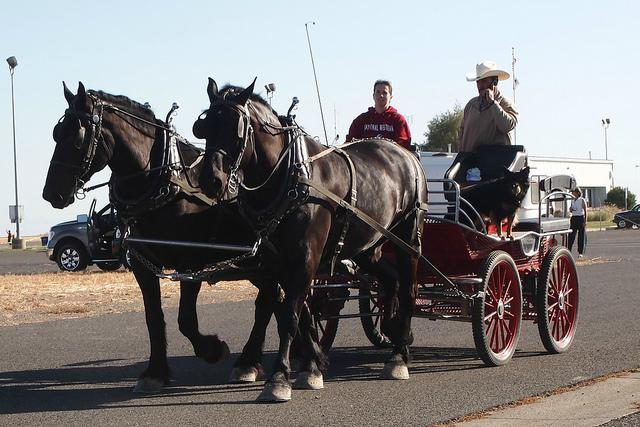What are the horses doing?

Choices:
A) resting
B) feeding
C) pulling cart
D) posing pulling cart 